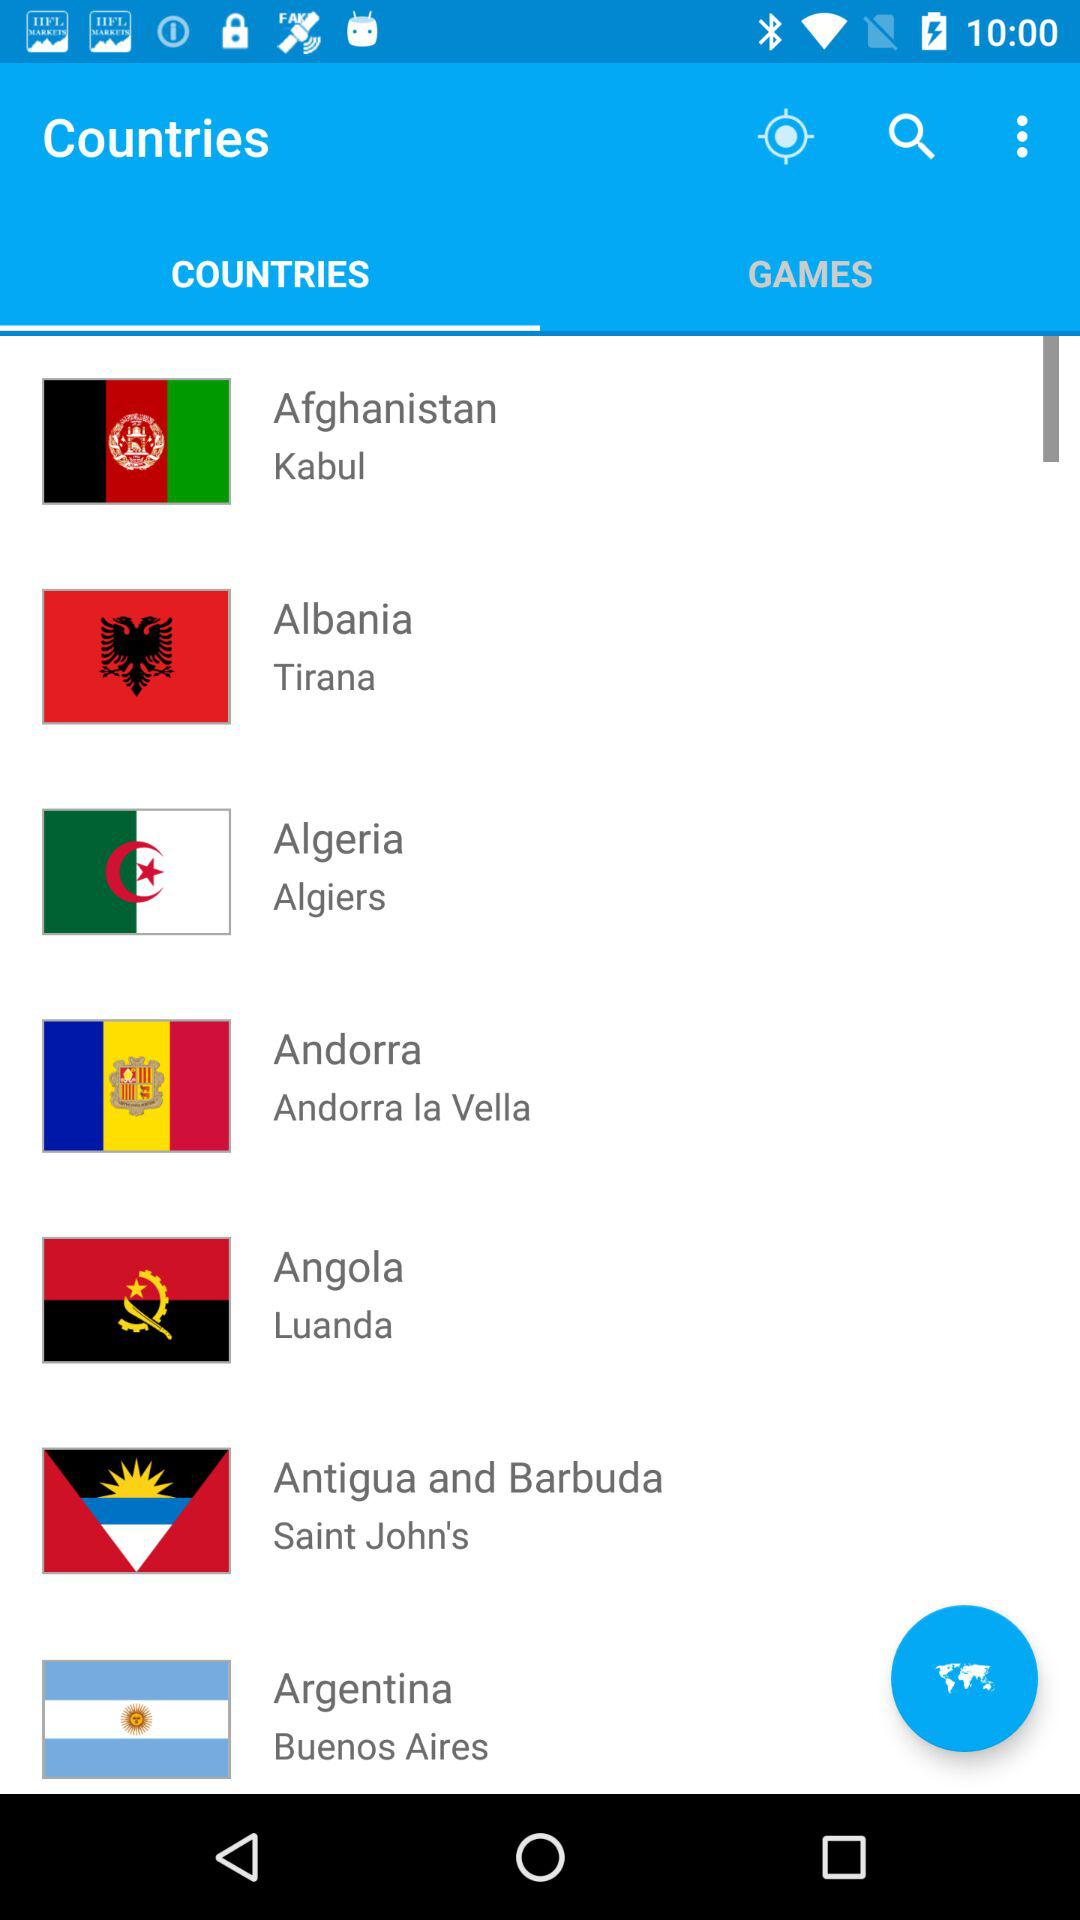What's the selected tab? The selected tab is "COUNTRIES". 